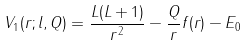<formula> <loc_0><loc_0><loc_500><loc_500>V _ { 1 } ( r ; l , Q ) = \frac { L ( L + 1 ) } { r ^ { 2 } } - \frac { Q } { r } f ( r ) - E _ { 0 }</formula> 